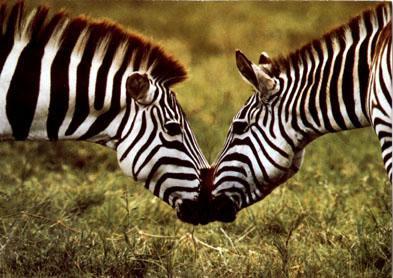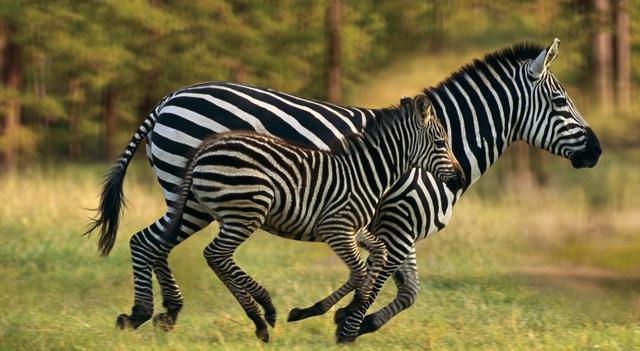The first image is the image on the left, the second image is the image on the right. Evaluate the accuracy of this statement regarding the images: "The left and right image contains the same number of zebras.". Is it true? Answer yes or no. Yes. The first image is the image on the left, the second image is the image on the right. Evaluate the accuracy of this statement regarding the images: "The right image contains two zebras with their noses touching, and the left image contains three zebras, with two facing each other over the body of the one in the middle.". Is it true? Answer yes or no. No. 